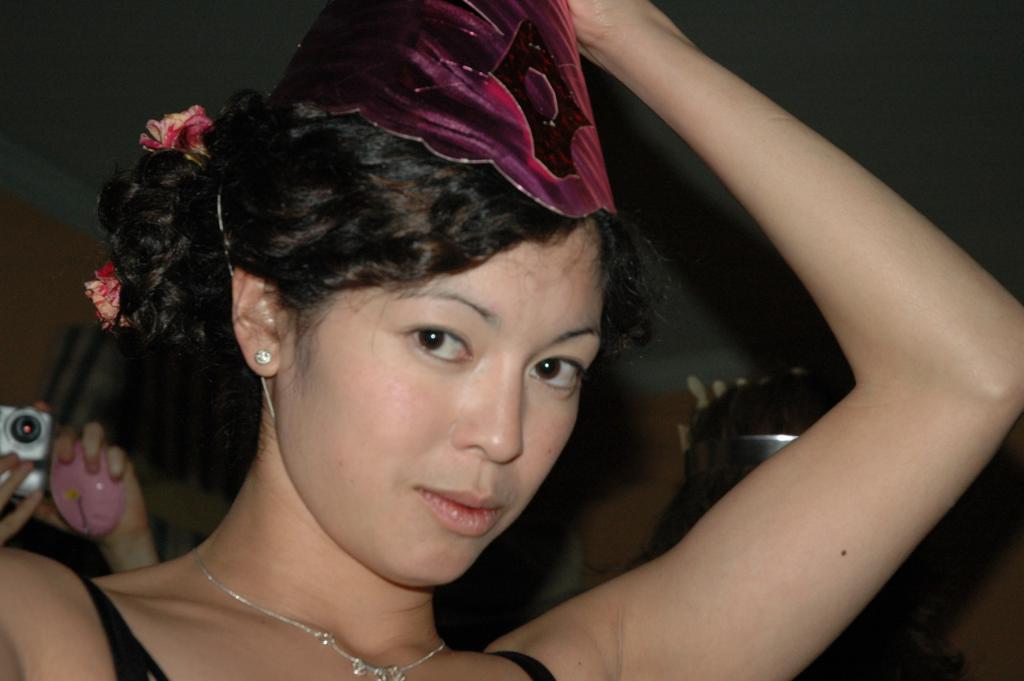How would you summarize this image in a sentence or two? In the image we can see a woman. Behind the woman few persons are standing and holding cameras. 